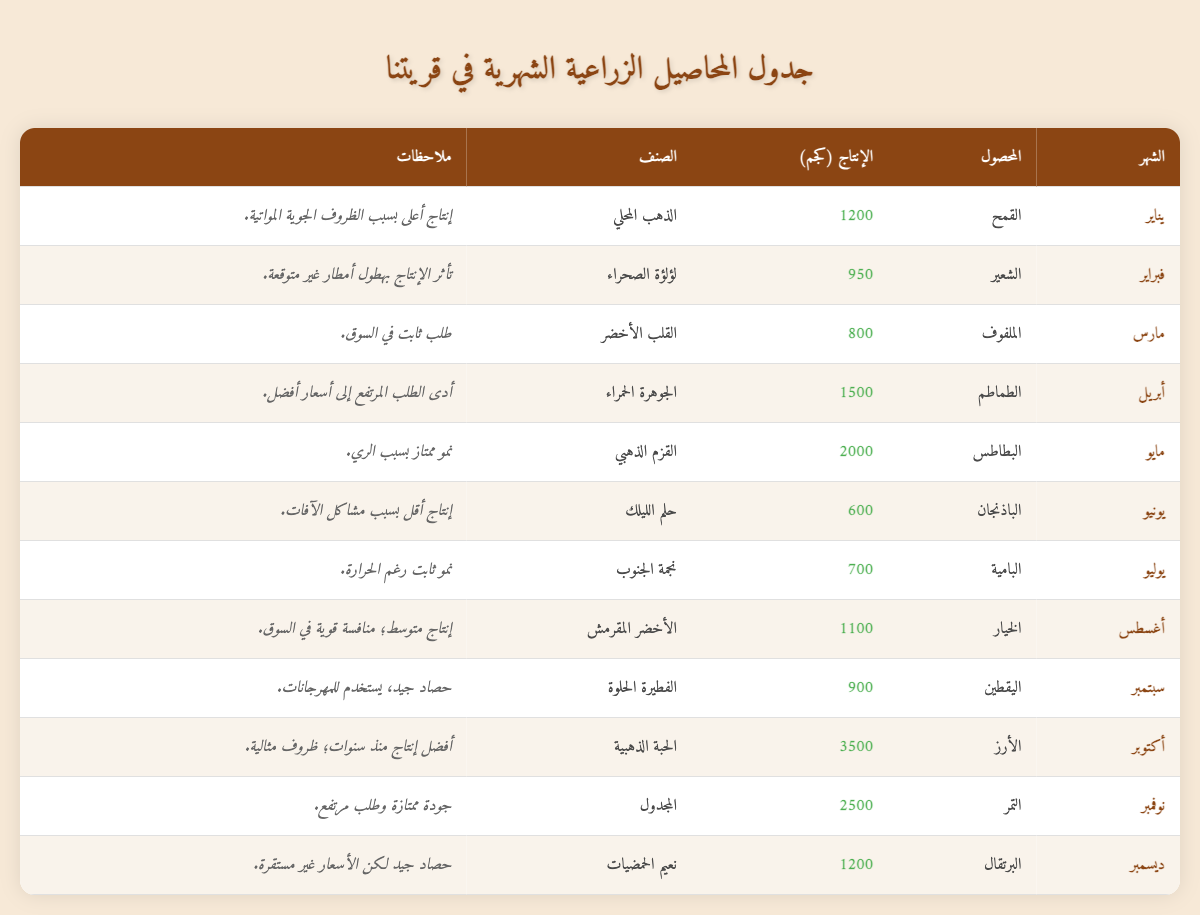ما هي إنتاجية القمح في يناير؟ يتم النظر في شهر يناير تحت عمود المحصول، حيث نجد أن إنتاجية القمح كانت 1200 كجم.
Answer: 1200 كجم ما هو المحصول الذي حقق أعلى إنتاجية في أكتوبر؟ عند مراجعة شهر أكتوبر، نجد أن المحصول هو الأرز، والذي حقق أعلى إنتاجية قدرها 3500 كجم.
Answer: 3500 كجم كم كان إجمالي الإنتاج من الطماطم والباذنجان؟ لإيجاد إجمالي الإنتاج، نجمع إنتاج الطماطم (1500 كجم) مع إنتاج الباذنجان (600 كجم). المجموع هو 1500 + 600 = 2100 كجم.
Answer: 2100 كجم هل كان هناك محصول واحد فقط حقق أقل إنتاجية؟ من النظر في الجدول، نجد أن الباذنجان له أقل إنتاجية مع 600 كجم وحده، مما يعني أن الإجابة هي نعم.
Answer: نعم كم كانت الإنتاجية المتوسطة لمحصول Dates و Rice؟ نجد أن محصول التمر حقق إنتاجية 2500 كجم، بينما الأرز حقق 3500 كجم. لحساب المتوسط، نجمع الاثنين (2500 + 3500 = 6000 كجم) ثم نقسم على 2، الناتج هو 6000/2 = 3000 كجم.
Answer: 3000 كجم ما هي المحاصيل التي كانت تحت ملاحظات "نمو ممتاز بسبب الري"؟ عند مراجعة الملاحظات، نجد أن البطاطس كانت تحت هذه الملاحظة.
Answer: البطاطس ما هو المحصول الذي حقق أفضل إنتاجية في نوفمبر؟ في شهر نوفمبر، نجد أن محصول التمر حقق أفضل إنتاجية، حيث بلغت 2500 كجم.
Answer: 2500 كجم كم عدد المحاصيل التي حققت إنتاجية تفوق 1000 كجم؟ عند مراجعة الجدول، نجد أن المحاصيل التي تجاوزت 1000 كجم هي: القمح (1200 كجم)، الطماطم (1500 كجم)، البطاطس (2000 كجم)، الأرز (3500 كجم)، والتمر (2500 كجم). المجموع هو 5 محاصيل.
Answer: 5 محاصيل 